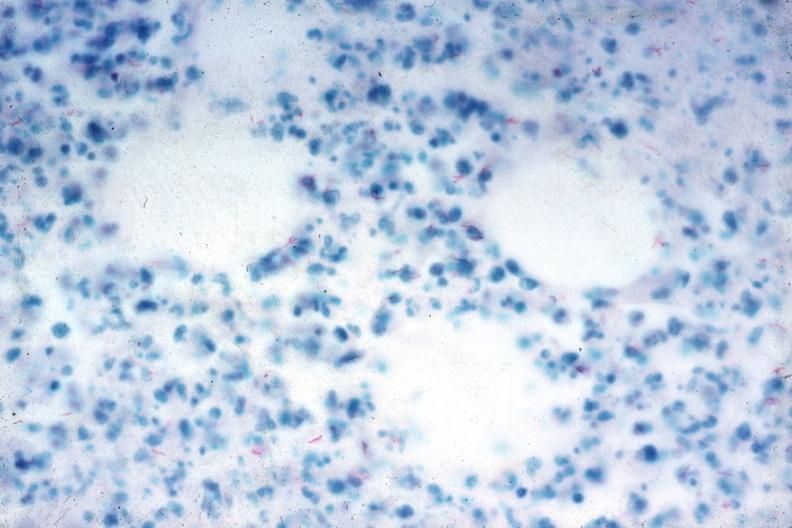what do acid stain?
Answer the question using a single word or phrase. Stain numerous fast bacilli very good slide 